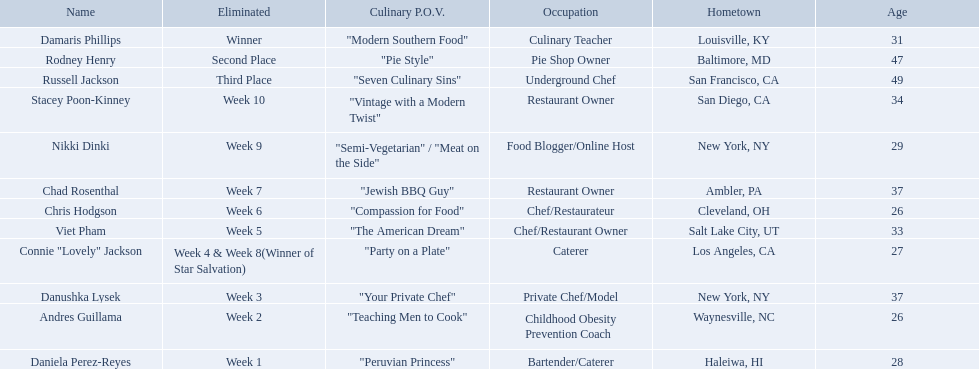Excluding the winner, and second and third place winners, who were the contestants eliminated? Stacey Poon-Kinney, Nikki Dinki, Chad Rosenthal, Chris Hodgson, Viet Pham, Connie "Lovely" Jackson, Danushka Lysek, Andres Guillama, Daniela Perez-Reyes. Could you help me parse every detail presented in this table? {'header': ['Name', 'Eliminated', 'Culinary P.O.V.', 'Occupation', 'Hometown', 'Age'], 'rows': [['Damaris Phillips', 'Winner', '"Modern Southern Food"', 'Culinary Teacher', 'Louisville, KY', '31'], ['Rodney Henry', 'Second Place', '"Pie Style"', 'Pie Shop Owner', 'Baltimore, MD', '47'], ['Russell Jackson', 'Third Place', '"Seven Culinary Sins"', 'Underground Chef', 'San Francisco, CA', '49'], ['Stacey Poon-Kinney', 'Week 10', '"Vintage with a Modern Twist"', 'Restaurant Owner', 'San Diego, CA', '34'], ['Nikki Dinki', 'Week 9', '"Semi-Vegetarian" / "Meat on the Side"', 'Food Blogger/Online Host', 'New York, NY', '29'], ['Chad Rosenthal', 'Week 7', '"Jewish BBQ Guy"', 'Restaurant Owner', 'Ambler, PA', '37'], ['Chris Hodgson', 'Week 6', '"Compassion for Food"', 'Chef/Restaurateur', 'Cleveland, OH', '26'], ['Viet Pham', 'Week 5', '"The American Dream"', 'Chef/Restaurant Owner', 'Salt Lake City, UT', '33'], ['Connie "Lovely" Jackson', 'Week 4 & Week 8(Winner of Star Salvation)', '"Party on a Plate"', 'Caterer', 'Los Angeles, CA', '27'], ['Danushka Lysek', 'Week 3', '"Your Private Chef"', 'Private Chef/Model', 'New York, NY', '37'], ['Andres Guillama', 'Week 2', '"Teaching Men to Cook"', 'Childhood Obesity Prevention Coach', 'Waynesville, NC', '26'], ['Daniela Perez-Reyes', 'Week 1', '"Peruvian Princess"', 'Bartender/Caterer', 'Haleiwa, HI', '28']]} Of these contestants, who were the last five eliminated before the winner, second, and third place winners were announce? Stacey Poon-Kinney, Nikki Dinki, Chad Rosenthal, Chris Hodgson, Viet Pham. Of these five contestants, was nikki dinki or viet pham eliminated first? Viet Pham. 